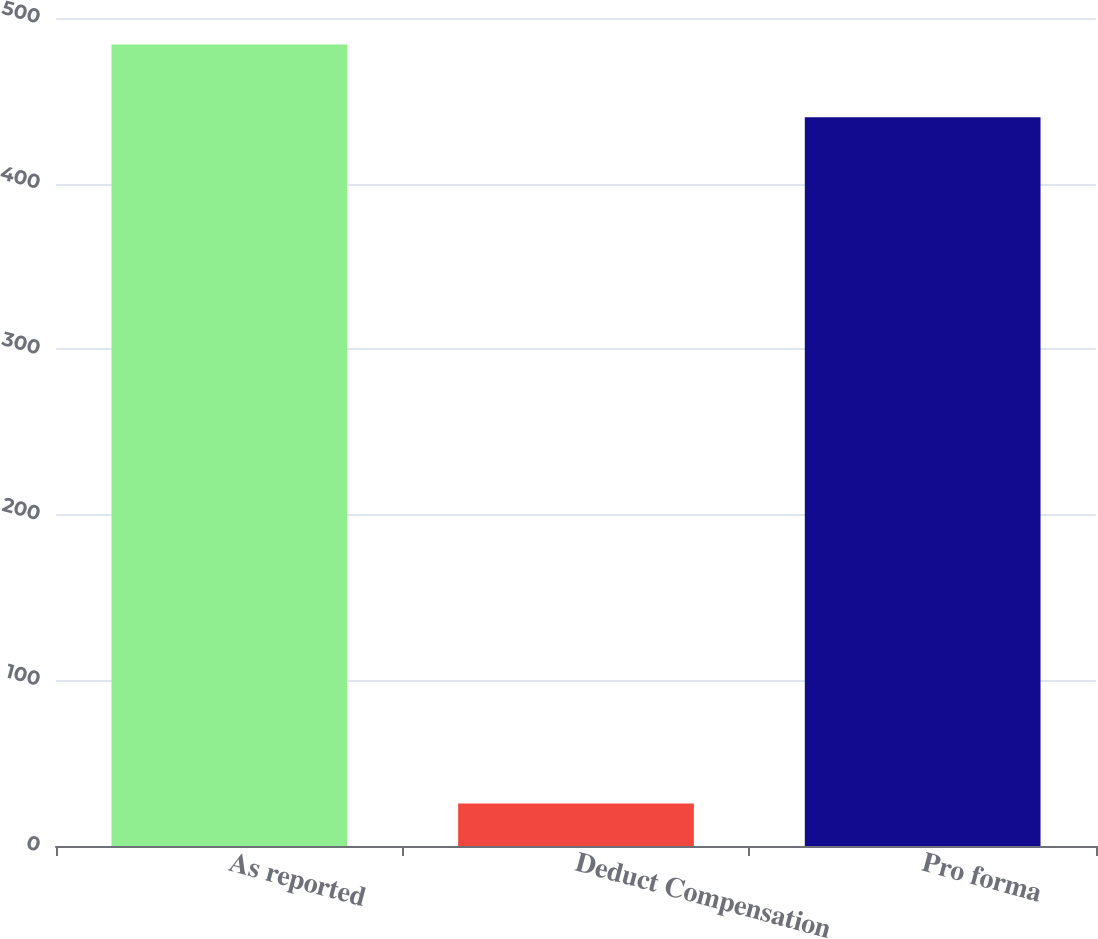<chart> <loc_0><loc_0><loc_500><loc_500><bar_chart><fcel>As reported<fcel>Deduct Compensation<fcel>Pro forma<nl><fcel>484<fcel>25.7<fcel>440<nl></chart> 